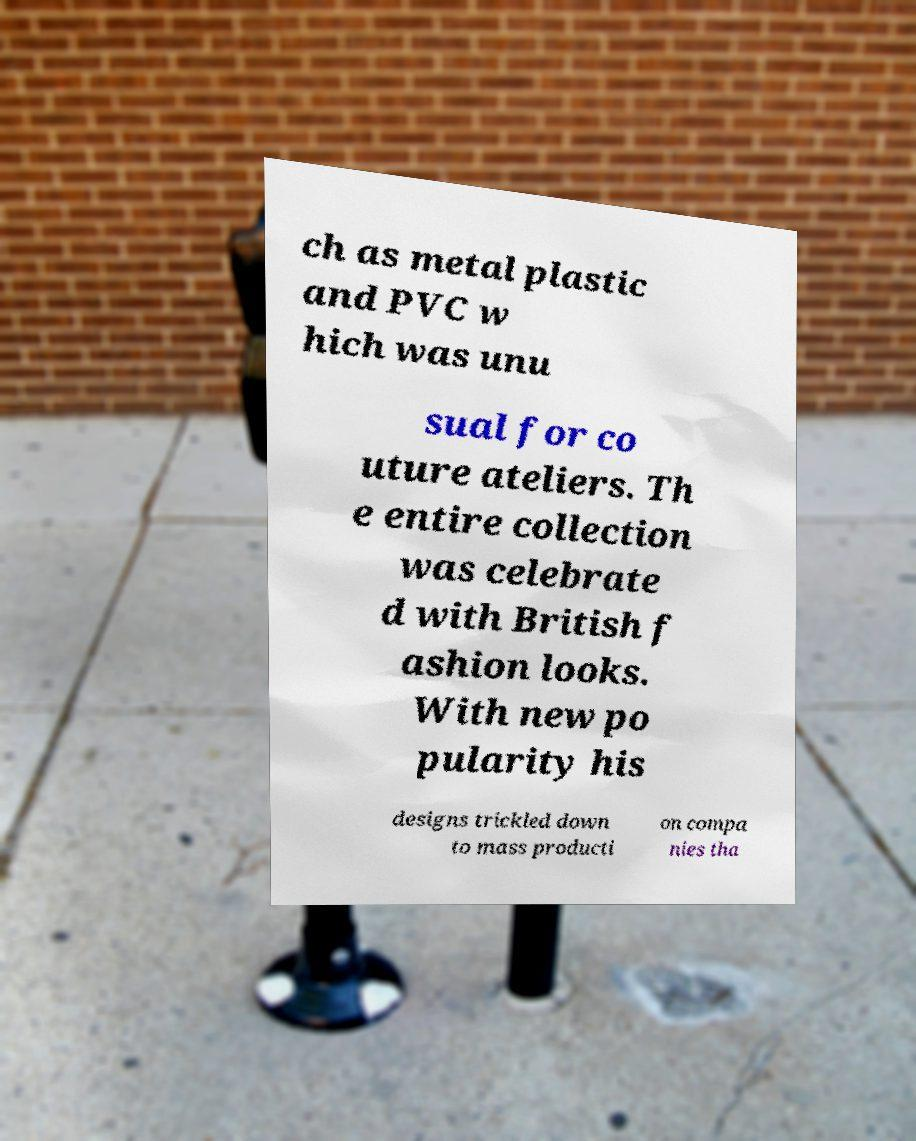I need the written content from this picture converted into text. Can you do that? ch as metal plastic and PVC w hich was unu sual for co uture ateliers. Th e entire collection was celebrate d with British f ashion looks. With new po pularity his designs trickled down to mass producti on compa nies tha 